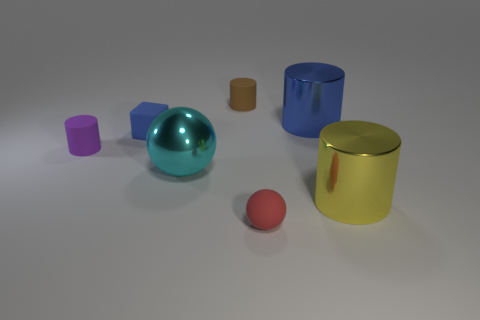Add 1 small blue rubber objects. How many objects exist? 8 Subtract all small brown matte cylinders. How many cylinders are left? 3 Subtract all cylinders. How many objects are left? 3 Subtract 1 blocks. How many blocks are left? 0 Subtract all purple cylinders. How many cyan cubes are left? 0 Subtract all large blue things. Subtract all large brown matte cylinders. How many objects are left? 6 Add 2 small red rubber things. How many small red rubber things are left? 3 Add 1 tiny objects. How many tiny objects exist? 5 Subtract all cyan spheres. How many spheres are left? 1 Subtract 0 yellow spheres. How many objects are left? 7 